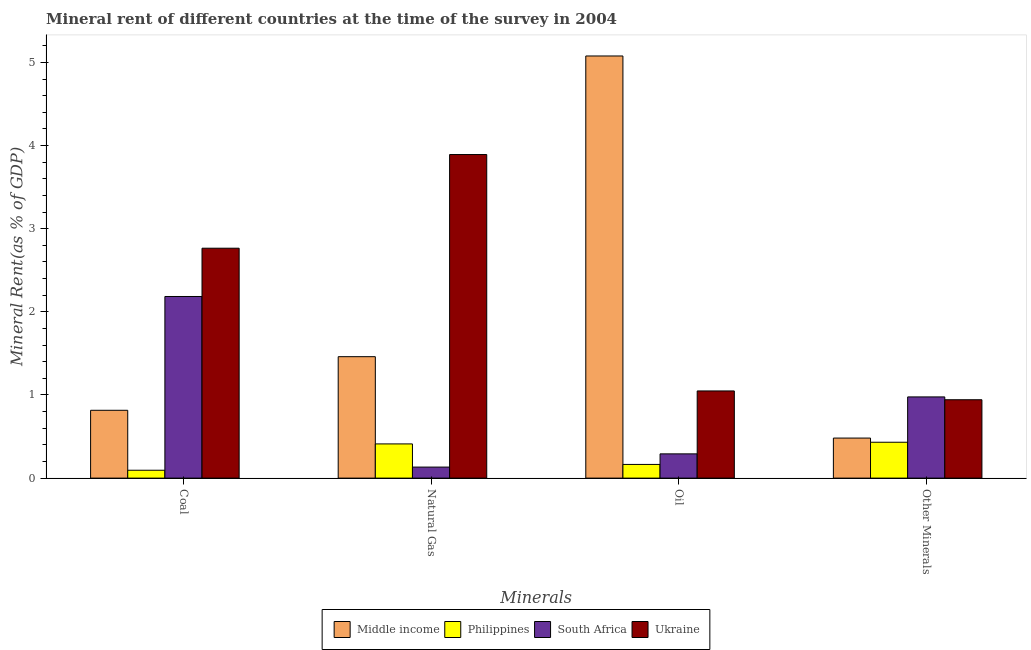How many groups of bars are there?
Your response must be concise. 4. Are the number of bars per tick equal to the number of legend labels?
Offer a very short reply. Yes. Are the number of bars on each tick of the X-axis equal?
Keep it short and to the point. Yes. How many bars are there on the 2nd tick from the left?
Ensure brevity in your answer.  4. How many bars are there on the 2nd tick from the right?
Your answer should be very brief. 4. What is the label of the 2nd group of bars from the left?
Provide a succinct answer. Natural Gas. What is the coal rent in Middle income?
Keep it short and to the point. 0.82. Across all countries, what is the maximum  rent of other minerals?
Your response must be concise. 0.98. Across all countries, what is the minimum oil rent?
Your response must be concise. 0.16. In which country was the natural gas rent maximum?
Provide a succinct answer. Ukraine. In which country was the natural gas rent minimum?
Your response must be concise. South Africa. What is the total coal rent in the graph?
Your answer should be very brief. 5.86. What is the difference between the oil rent in South Africa and that in Ukraine?
Offer a terse response. -0.76. What is the difference between the coal rent in Ukraine and the natural gas rent in Philippines?
Your response must be concise. 2.35. What is the average natural gas rent per country?
Offer a terse response. 1.47. What is the difference between the  rent of other minerals and natural gas rent in Ukraine?
Make the answer very short. -2.95. In how many countries, is the coal rent greater than 3.6 %?
Give a very brief answer. 0. What is the ratio of the coal rent in Ukraine to that in Philippines?
Ensure brevity in your answer.  29.18. Is the oil rent in Middle income less than that in South Africa?
Provide a short and direct response. No. What is the difference between the highest and the second highest oil rent?
Make the answer very short. 4.03. What is the difference between the highest and the lowest coal rent?
Ensure brevity in your answer.  2.67. Is the sum of the  rent of other minerals in Ukraine and Middle income greater than the maximum coal rent across all countries?
Provide a short and direct response. No. Is it the case that in every country, the sum of the  rent of other minerals and coal rent is greater than the sum of oil rent and natural gas rent?
Your answer should be very brief. No. What does the 4th bar from the left in Other Minerals represents?
Keep it short and to the point. Ukraine. What does the 2nd bar from the right in Other Minerals represents?
Offer a terse response. South Africa. Is it the case that in every country, the sum of the coal rent and natural gas rent is greater than the oil rent?
Provide a succinct answer. No. Are all the bars in the graph horizontal?
Give a very brief answer. No. What is the difference between two consecutive major ticks on the Y-axis?
Your response must be concise. 1. Are the values on the major ticks of Y-axis written in scientific E-notation?
Your answer should be compact. No. Where does the legend appear in the graph?
Your answer should be very brief. Bottom center. What is the title of the graph?
Your answer should be compact. Mineral rent of different countries at the time of the survey in 2004. Does "Paraguay" appear as one of the legend labels in the graph?
Make the answer very short. No. What is the label or title of the X-axis?
Give a very brief answer. Minerals. What is the label or title of the Y-axis?
Your answer should be very brief. Mineral Rent(as % of GDP). What is the Mineral Rent(as % of GDP) of Middle income in Coal?
Your answer should be very brief. 0.82. What is the Mineral Rent(as % of GDP) of Philippines in Coal?
Your answer should be very brief. 0.09. What is the Mineral Rent(as % of GDP) of South Africa in Coal?
Keep it short and to the point. 2.18. What is the Mineral Rent(as % of GDP) of Ukraine in Coal?
Your response must be concise. 2.77. What is the Mineral Rent(as % of GDP) in Middle income in Natural Gas?
Offer a very short reply. 1.46. What is the Mineral Rent(as % of GDP) of Philippines in Natural Gas?
Offer a terse response. 0.41. What is the Mineral Rent(as % of GDP) of South Africa in Natural Gas?
Your answer should be compact. 0.13. What is the Mineral Rent(as % of GDP) of Ukraine in Natural Gas?
Your answer should be very brief. 3.89. What is the Mineral Rent(as % of GDP) of Middle income in Oil?
Provide a short and direct response. 5.08. What is the Mineral Rent(as % of GDP) of Philippines in Oil?
Keep it short and to the point. 0.16. What is the Mineral Rent(as % of GDP) of South Africa in Oil?
Give a very brief answer. 0.29. What is the Mineral Rent(as % of GDP) of Ukraine in Oil?
Give a very brief answer. 1.05. What is the Mineral Rent(as % of GDP) in Middle income in Other Minerals?
Your response must be concise. 0.48. What is the Mineral Rent(as % of GDP) in Philippines in Other Minerals?
Provide a succinct answer. 0.43. What is the Mineral Rent(as % of GDP) in South Africa in Other Minerals?
Make the answer very short. 0.98. What is the Mineral Rent(as % of GDP) of Ukraine in Other Minerals?
Provide a short and direct response. 0.94. Across all Minerals, what is the maximum Mineral Rent(as % of GDP) of Middle income?
Your answer should be compact. 5.08. Across all Minerals, what is the maximum Mineral Rent(as % of GDP) of Philippines?
Give a very brief answer. 0.43. Across all Minerals, what is the maximum Mineral Rent(as % of GDP) in South Africa?
Provide a short and direct response. 2.18. Across all Minerals, what is the maximum Mineral Rent(as % of GDP) of Ukraine?
Make the answer very short. 3.89. Across all Minerals, what is the minimum Mineral Rent(as % of GDP) in Middle income?
Offer a very short reply. 0.48. Across all Minerals, what is the minimum Mineral Rent(as % of GDP) in Philippines?
Offer a very short reply. 0.09. Across all Minerals, what is the minimum Mineral Rent(as % of GDP) of South Africa?
Provide a short and direct response. 0.13. Across all Minerals, what is the minimum Mineral Rent(as % of GDP) in Ukraine?
Provide a short and direct response. 0.94. What is the total Mineral Rent(as % of GDP) of Middle income in the graph?
Your answer should be very brief. 7.84. What is the total Mineral Rent(as % of GDP) of Philippines in the graph?
Provide a short and direct response. 1.1. What is the total Mineral Rent(as % of GDP) of South Africa in the graph?
Ensure brevity in your answer.  3.59. What is the total Mineral Rent(as % of GDP) of Ukraine in the graph?
Your answer should be compact. 8.65. What is the difference between the Mineral Rent(as % of GDP) of Middle income in Coal and that in Natural Gas?
Ensure brevity in your answer.  -0.64. What is the difference between the Mineral Rent(as % of GDP) of Philippines in Coal and that in Natural Gas?
Make the answer very short. -0.32. What is the difference between the Mineral Rent(as % of GDP) of South Africa in Coal and that in Natural Gas?
Your answer should be very brief. 2.05. What is the difference between the Mineral Rent(as % of GDP) in Ukraine in Coal and that in Natural Gas?
Your response must be concise. -1.13. What is the difference between the Mineral Rent(as % of GDP) in Middle income in Coal and that in Oil?
Your answer should be very brief. -4.26. What is the difference between the Mineral Rent(as % of GDP) of Philippines in Coal and that in Oil?
Your answer should be compact. -0.07. What is the difference between the Mineral Rent(as % of GDP) in South Africa in Coal and that in Oil?
Ensure brevity in your answer.  1.89. What is the difference between the Mineral Rent(as % of GDP) of Ukraine in Coal and that in Oil?
Your answer should be compact. 1.72. What is the difference between the Mineral Rent(as % of GDP) in Middle income in Coal and that in Other Minerals?
Provide a short and direct response. 0.33. What is the difference between the Mineral Rent(as % of GDP) in Philippines in Coal and that in Other Minerals?
Ensure brevity in your answer.  -0.34. What is the difference between the Mineral Rent(as % of GDP) of South Africa in Coal and that in Other Minerals?
Ensure brevity in your answer.  1.21. What is the difference between the Mineral Rent(as % of GDP) of Ukraine in Coal and that in Other Minerals?
Give a very brief answer. 1.82. What is the difference between the Mineral Rent(as % of GDP) in Middle income in Natural Gas and that in Oil?
Your answer should be compact. -3.62. What is the difference between the Mineral Rent(as % of GDP) of Philippines in Natural Gas and that in Oil?
Make the answer very short. 0.25. What is the difference between the Mineral Rent(as % of GDP) of South Africa in Natural Gas and that in Oil?
Keep it short and to the point. -0.16. What is the difference between the Mineral Rent(as % of GDP) in Ukraine in Natural Gas and that in Oil?
Offer a terse response. 2.84. What is the difference between the Mineral Rent(as % of GDP) of Middle income in Natural Gas and that in Other Minerals?
Give a very brief answer. 0.98. What is the difference between the Mineral Rent(as % of GDP) in Philippines in Natural Gas and that in Other Minerals?
Offer a very short reply. -0.02. What is the difference between the Mineral Rent(as % of GDP) of South Africa in Natural Gas and that in Other Minerals?
Offer a terse response. -0.84. What is the difference between the Mineral Rent(as % of GDP) of Ukraine in Natural Gas and that in Other Minerals?
Provide a succinct answer. 2.95. What is the difference between the Mineral Rent(as % of GDP) in Middle income in Oil and that in Other Minerals?
Your response must be concise. 4.6. What is the difference between the Mineral Rent(as % of GDP) of Philippines in Oil and that in Other Minerals?
Offer a very short reply. -0.27. What is the difference between the Mineral Rent(as % of GDP) in South Africa in Oil and that in Other Minerals?
Your answer should be compact. -0.69. What is the difference between the Mineral Rent(as % of GDP) in Ukraine in Oil and that in Other Minerals?
Provide a short and direct response. 0.11. What is the difference between the Mineral Rent(as % of GDP) of Middle income in Coal and the Mineral Rent(as % of GDP) of Philippines in Natural Gas?
Keep it short and to the point. 0.4. What is the difference between the Mineral Rent(as % of GDP) of Middle income in Coal and the Mineral Rent(as % of GDP) of South Africa in Natural Gas?
Your response must be concise. 0.68. What is the difference between the Mineral Rent(as % of GDP) of Middle income in Coal and the Mineral Rent(as % of GDP) of Ukraine in Natural Gas?
Offer a terse response. -3.08. What is the difference between the Mineral Rent(as % of GDP) in Philippines in Coal and the Mineral Rent(as % of GDP) in South Africa in Natural Gas?
Provide a succinct answer. -0.04. What is the difference between the Mineral Rent(as % of GDP) of Philippines in Coal and the Mineral Rent(as % of GDP) of Ukraine in Natural Gas?
Make the answer very short. -3.8. What is the difference between the Mineral Rent(as % of GDP) of South Africa in Coal and the Mineral Rent(as % of GDP) of Ukraine in Natural Gas?
Make the answer very short. -1.71. What is the difference between the Mineral Rent(as % of GDP) of Middle income in Coal and the Mineral Rent(as % of GDP) of Philippines in Oil?
Offer a very short reply. 0.65. What is the difference between the Mineral Rent(as % of GDP) in Middle income in Coal and the Mineral Rent(as % of GDP) in South Africa in Oil?
Give a very brief answer. 0.52. What is the difference between the Mineral Rent(as % of GDP) of Middle income in Coal and the Mineral Rent(as % of GDP) of Ukraine in Oil?
Keep it short and to the point. -0.23. What is the difference between the Mineral Rent(as % of GDP) in Philippines in Coal and the Mineral Rent(as % of GDP) in South Africa in Oil?
Ensure brevity in your answer.  -0.2. What is the difference between the Mineral Rent(as % of GDP) of Philippines in Coal and the Mineral Rent(as % of GDP) of Ukraine in Oil?
Offer a very short reply. -0.95. What is the difference between the Mineral Rent(as % of GDP) in South Africa in Coal and the Mineral Rent(as % of GDP) in Ukraine in Oil?
Provide a short and direct response. 1.14. What is the difference between the Mineral Rent(as % of GDP) of Middle income in Coal and the Mineral Rent(as % of GDP) of Philippines in Other Minerals?
Give a very brief answer. 0.38. What is the difference between the Mineral Rent(as % of GDP) in Middle income in Coal and the Mineral Rent(as % of GDP) in South Africa in Other Minerals?
Your response must be concise. -0.16. What is the difference between the Mineral Rent(as % of GDP) in Middle income in Coal and the Mineral Rent(as % of GDP) in Ukraine in Other Minerals?
Your response must be concise. -0.13. What is the difference between the Mineral Rent(as % of GDP) of Philippines in Coal and the Mineral Rent(as % of GDP) of South Africa in Other Minerals?
Provide a short and direct response. -0.88. What is the difference between the Mineral Rent(as % of GDP) in Philippines in Coal and the Mineral Rent(as % of GDP) in Ukraine in Other Minerals?
Provide a short and direct response. -0.85. What is the difference between the Mineral Rent(as % of GDP) of South Africa in Coal and the Mineral Rent(as % of GDP) of Ukraine in Other Minerals?
Your answer should be compact. 1.24. What is the difference between the Mineral Rent(as % of GDP) of Middle income in Natural Gas and the Mineral Rent(as % of GDP) of Philippines in Oil?
Provide a short and direct response. 1.3. What is the difference between the Mineral Rent(as % of GDP) of Middle income in Natural Gas and the Mineral Rent(as % of GDP) of South Africa in Oil?
Your response must be concise. 1.17. What is the difference between the Mineral Rent(as % of GDP) of Middle income in Natural Gas and the Mineral Rent(as % of GDP) of Ukraine in Oil?
Your answer should be very brief. 0.41. What is the difference between the Mineral Rent(as % of GDP) in Philippines in Natural Gas and the Mineral Rent(as % of GDP) in South Africa in Oil?
Ensure brevity in your answer.  0.12. What is the difference between the Mineral Rent(as % of GDP) of Philippines in Natural Gas and the Mineral Rent(as % of GDP) of Ukraine in Oil?
Keep it short and to the point. -0.64. What is the difference between the Mineral Rent(as % of GDP) of South Africa in Natural Gas and the Mineral Rent(as % of GDP) of Ukraine in Oil?
Keep it short and to the point. -0.92. What is the difference between the Mineral Rent(as % of GDP) in Middle income in Natural Gas and the Mineral Rent(as % of GDP) in Philippines in Other Minerals?
Provide a succinct answer. 1.03. What is the difference between the Mineral Rent(as % of GDP) of Middle income in Natural Gas and the Mineral Rent(as % of GDP) of South Africa in Other Minerals?
Your answer should be very brief. 0.48. What is the difference between the Mineral Rent(as % of GDP) in Middle income in Natural Gas and the Mineral Rent(as % of GDP) in Ukraine in Other Minerals?
Keep it short and to the point. 0.52. What is the difference between the Mineral Rent(as % of GDP) of Philippines in Natural Gas and the Mineral Rent(as % of GDP) of South Africa in Other Minerals?
Your answer should be very brief. -0.57. What is the difference between the Mineral Rent(as % of GDP) in Philippines in Natural Gas and the Mineral Rent(as % of GDP) in Ukraine in Other Minerals?
Offer a very short reply. -0.53. What is the difference between the Mineral Rent(as % of GDP) in South Africa in Natural Gas and the Mineral Rent(as % of GDP) in Ukraine in Other Minerals?
Your answer should be very brief. -0.81. What is the difference between the Mineral Rent(as % of GDP) of Middle income in Oil and the Mineral Rent(as % of GDP) of Philippines in Other Minerals?
Your answer should be very brief. 4.65. What is the difference between the Mineral Rent(as % of GDP) of Middle income in Oil and the Mineral Rent(as % of GDP) of South Africa in Other Minerals?
Offer a terse response. 4.1. What is the difference between the Mineral Rent(as % of GDP) in Middle income in Oil and the Mineral Rent(as % of GDP) in Ukraine in Other Minerals?
Your response must be concise. 4.13. What is the difference between the Mineral Rent(as % of GDP) of Philippines in Oil and the Mineral Rent(as % of GDP) of South Africa in Other Minerals?
Ensure brevity in your answer.  -0.81. What is the difference between the Mineral Rent(as % of GDP) of Philippines in Oil and the Mineral Rent(as % of GDP) of Ukraine in Other Minerals?
Your response must be concise. -0.78. What is the difference between the Mineral Rent(as % of GDP) of South Africa in Oil and the Mineral Rent(as % of GDP) of Ukraine in Other Minerals?
Ensure brevity in your answer.  -0.65. What is the average Mineral Rent(as % of GDP) of Middle income per Minerals?
Provide a short and direct response. 1.96. What is the average Mineral Rent(as % of GDP) in Philippines per Minerals?
Provide a succinct answer. 0.28. What is the average Mineral Rent(as % of GDP) in South Africa per Minerals?
Ensure brevity in your answer.  0.9. What is the average Mineral Rent(as % of GDP) of Ukraine per Minerals?
Keep it short and to the point. 2.16. What is the difference between the Mineral Rent(as % of GDP) of Middle income and Mineral Rent(as % of GDP) of Philippines in Coal?
Give a very brief answer. 0.72. What is the difference between the Mineral Rent(as % of GDP) of Middle income and Mineral Rent(as % of GDP) of South Africa in Coal?
Your response must be concise. -1.37. What is the difference between the Mineral Rent(as % of GDP) of Middle income and Mineral Rent(as % of GDP) of Ukraine in Coal?
Ensure brevity in your answer.  -1.95. What is the difference between the Mineral Rent(as % of GDP) of Philippines and Mineral Rent(as % of GDP) of South Africa in Coal?
Provide a short and direct response. -2.09. What is the difference between the Mineral Rent(as % of GDP) in Philippines and Mineral Rent(as % of GDP) in Ukraine in Coal?
Ensure brevity in your answer.  -2.67. What is the difference between the Mineral Rent(as % of GDP) in South Africa and Mineral Rent(as % of GDP) in Ukraine in Coal?
Provide a succinct answer. -0.58. What is the difference between the Mineral Rent(as % of GDP) of Middle income and Mineral Rent(as % of GDP) of Philippines in Natural Gas?
Offer a terse response. 1.05. What is the difference between the Mineral Rent(as % of GDP) in Middle income and Mineral Rent(as % of GDP) in South Africa in Natural Gas?
Offer a terse response. 1.33. What is the difference between the Mineral Rent(as % of GDP) in Middle income and Mineral Rent(as % of GDP) in Ukraine in Natural Gas?
Give a very brief answer. -2.43. What is the difference between the Mineral Rent(as % of GDP) in Philippines and Mineral Rent(as % of GDP) in South Africa in Natural Gas?
Your response must be concise. 0.28. What is the difference between the Mineral Rent(as % of GDP) in Philippines and Mineral Rent(as % of GDP) in Ukraine in Natural Gas?
Keep it short and to the point. -3.48. What is the difference between the Mineral Rent(as % of GDP) of South Africa and Mineral Rent(as % of GDP) of Ukraine in Natural Gas?
Your answer should be compact. -3.76. What is the difference between the Mineral Rent(as % of GDP) in Middle income and Mineral Rent(as % of GDP) in Philippines in Oil?
Ensure brevity in your answer.  4.91. What is the difference between the Mineral Rent(as % of GDP) in Middle income and Mineral Rent(as % of GDP) in South Africa in Oil?
Your answer should be very brief. 4.79. What is the difference between the Mineral Rent(as % of GDP) of Middle income and Mineral Rent(as % of GDP) of Ukraine in Oil?
Offer a very short reply. 4.03. What is the difference between the Mineral Rent(as % of GDP) of Philippines and Mineral Rent(as % of GDP) of South Africa in Oil?
Make the answer very short. -0.13. What is the difference between the Mineral Rent(as % of GDP) of Philippines and Mineral Rent(as % of GDP) of Ukraine in Oil?
Offer a very short reply. -0.88. What is the difference between the Mineral Rent(as % of GDP) in South Africa and Mineral Rent(as % of GDP) in Ukraine in Oil?
Your answer should be very brief. -0.76. What is the difference between the Mineral Rent(as % of GDP) of Middle income and Mineral Rent(as % of GDP) of Philippines in Other Minerals?
Provide a succinct answer. 0.05. What is the difference between the Mineral Rent(as % of GDP) in Middle income and Mineral Rent(as % of GDP) in South Africa in Other Minerals?
Make the answer very short. -0.5. What is the difference between the Mineral Rent(as % of GDP) of Middle income and Mineral Rent(as % of GDP) of Ukraine in Other Minerals?
Give a very brief answer. -0.46. What is the difference between the Mineral Rent(as % of GDP) of Philippines and Mineral Rent(as % of GDP) of South Africa in Other Minerals?
Your answer should be compact. -0.55. What is the difference between the Mineral Rent(as % of GDP) in Philippines and Mineral Rent(as % of GDP) in Ukraine in Other Minerals?
Offer a terse response. -0.51. What is the difference between the Mineral Rent(as % of GDP) of South Africa and Mineral Rent(as % of GDP) of Ukraine in Other Minerals?
Make the answer very short. 0.03. What is the ratio of the Mineral Rent(as % of GDP) in Middle income in Coal to that in Natural Gas?
Your answer should be compact. 0.56. What is the ratio of the Mineral Rent(as % of GDP) in Philippines in Coal to that in Natural Gas?
Give a very brief answer. 0.23. What is the ratio of the Mineral Rent(as % of GDP) in South Africa in Coal to that in Natural Gas?
Provide a short and direct response. 16.47. What is the ratio of the Mineral Rent(as % of GDP) of Ukraine in Coal to that in Natural Gas?
Your answer should be very brief. 0.71. What is the ratio of the Mineral Rent(as % of GDP) of Middle income in Coal to that in Oil?
Your answer should be compact. 0.16. What is the ratio of the Mineral Rent(as % of GDP) of Philippines in Coal to that in Oil?
Keep it short and to the point. 0.58. What is the ratio of the Mineral Rent(as % of GDP) of South Africa in Coal to that in Oil?
Your answer should be very brief. 7.49. What is the ratio of the Mineral Rent(as % of GDP) in Ukraine in Coal to that in Oil?
Offer a very short reply. 2.64. What is the ratio of the Mineral Rent(as % of GDP) in Middle income in Coal to that in Other Minerals?
Give a very brief answer. 1.69. What is the ratio of the Mineral Rent(as % of GDP) of Philippines in Coal to that in Other Minerals?
Your response must be concise. 0.22. What is the ratio of the Mineral Rent(as % of GDP) of South Africa in Coal to that in Other Minerals?
Offer a terse response. 2.24. What is the ratio of the Mineral Rent(as % of GDP) of Ukraine in Coal to that in Other Minerals?
Ensure brevity in your answer.  2.93. What is the ratio of the Mineral Rent(as % of GDP) in Middle income in Natural Gas to that in Oil?
Ensure brevity in your answer.  0.29. What is the ratio of the Mineral Rent(as % of GDP) in Philippines in Natural Gas to that in Oil?
Make the answer very short. 2.5. What is the ratio of the Mineral Rent(as % of GDP) of South Africa in Natural Gas to that in Oil?
Offer a very short reply. 0.45. What is the ratio of the Mineral Rent(as % of GDP) in Ukraine in Natural Gas to that in Oil?
Your answer should be very brief. 3.71. What is the ratio of the Mineral Rent(as % of GDP) in Middle income in Natural Gas to that in Other Minerals?
Your response must be concise. 3.03. What is the ratio of the Mineral Rent(as % of GDP) in Philippines in Natural Gas to that in Other Minerals?
Your answer should be very brief. 0.95. What is the ratio of the Mineral Rent(as % of GDP) in South Africa in Natural Gas to that in Other Minerals?
Offer a terse response. 0.14. What is the ratio of the Mineral Rent(as % of GDP) in Ukraine in Natural Gas to that in Other Minerals?
Provide a succinct answer. 4.13. What is the ratio of the Mineral Rent(as % of GDP) in Middle income in Oil to that in Other Minerals?
Offer a very short reply. 10.54. What is the ratio of the Mineral Rent(as % of GDP) in Philippines in Oil to that in Other Minerals?
Provide a succinct answer. 0.38. What is the ratio of the Mineral Rent(as % of GDP) of South Africa in Oil to that in Other Minerals?
Make the answer very short. 0.3. What is the ratio of the Mineral Rent(as % of GDP) of Ukraine in Oil to that in Other Minerals?
Your answer should be very brief. 1.11. What is the difference between the highest and the second highest Mineral Rent(as % of GDP) of Middle income?
Make the answer very short. 3.62. What is the difference between the highest and the second highest Mineral Rent(as % of GDP) in Philippines?
Provide a short and direct response. 0.02. What is the difference between the highest and the second highest Mineral Rent(as % of GDP) in South Africa?
Give a very brief answer. 1.21. What is the difference between the highest and the second highest Mineral Rent(as % of GDP) of Ukraine?
Offer a very short reply. 1.13. What is the difference between the highest and the lowest Mineral Rent(as % of GDP) in Middle income?
Make the answer very short. 4.6. What is the difference between the highest and the lowest Mineral Rent(as % of GDP) in Philippines?
Your response must be concise. 0.34. What is the difference between the highest and the lowest Mineral Rent(as % of GDP) in South Africa?
Offer a very short reply. 2.05. What is the difference between the highest and the lowest Mineral Rent(as % of GDP) in Ukraine?
Offer a very short reply. 2.95. 